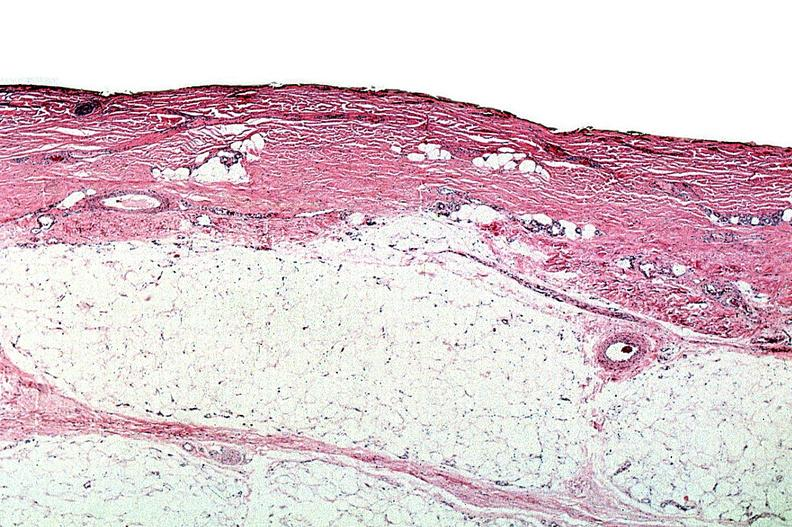does this image show thermal burned skin?
Answer the question using a single word or phrase. Yes 